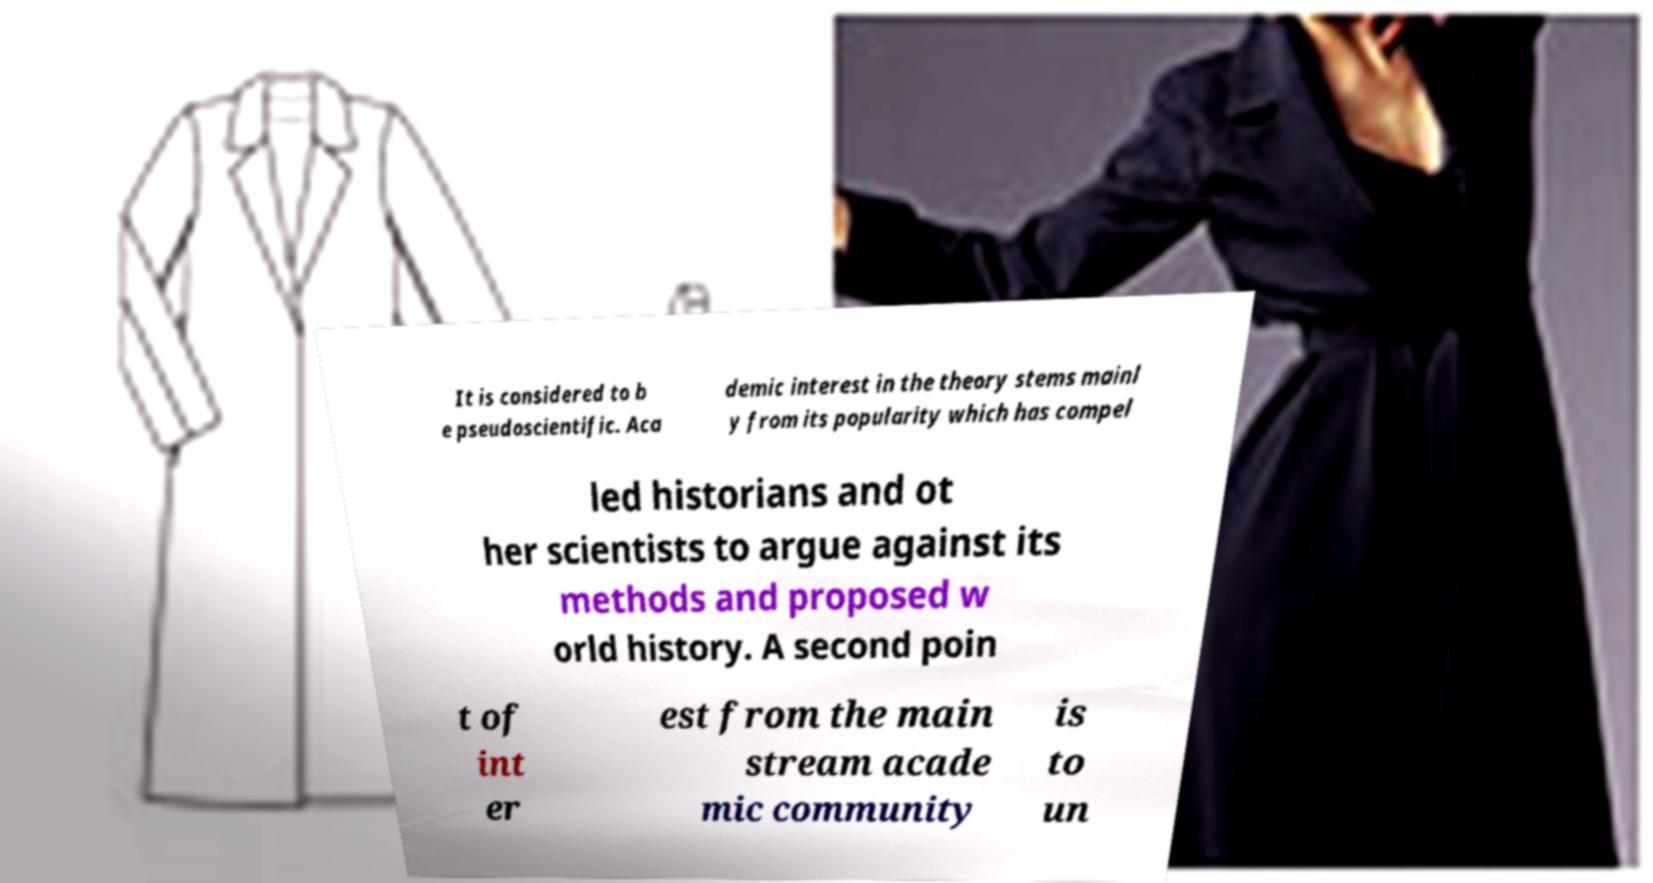Can you read and provide the text displayed in the image?This photo seems to have some interesting text. Can you extract and type it out for me? It is considered to b e pseudoscientific. Aca demic interest in the theory stems mainl y from its popularity which has compel led historians and ot her scientists to argue against its methods and proposed w orld history. A second poin t of int er est from the main stream acade mic community is to un 